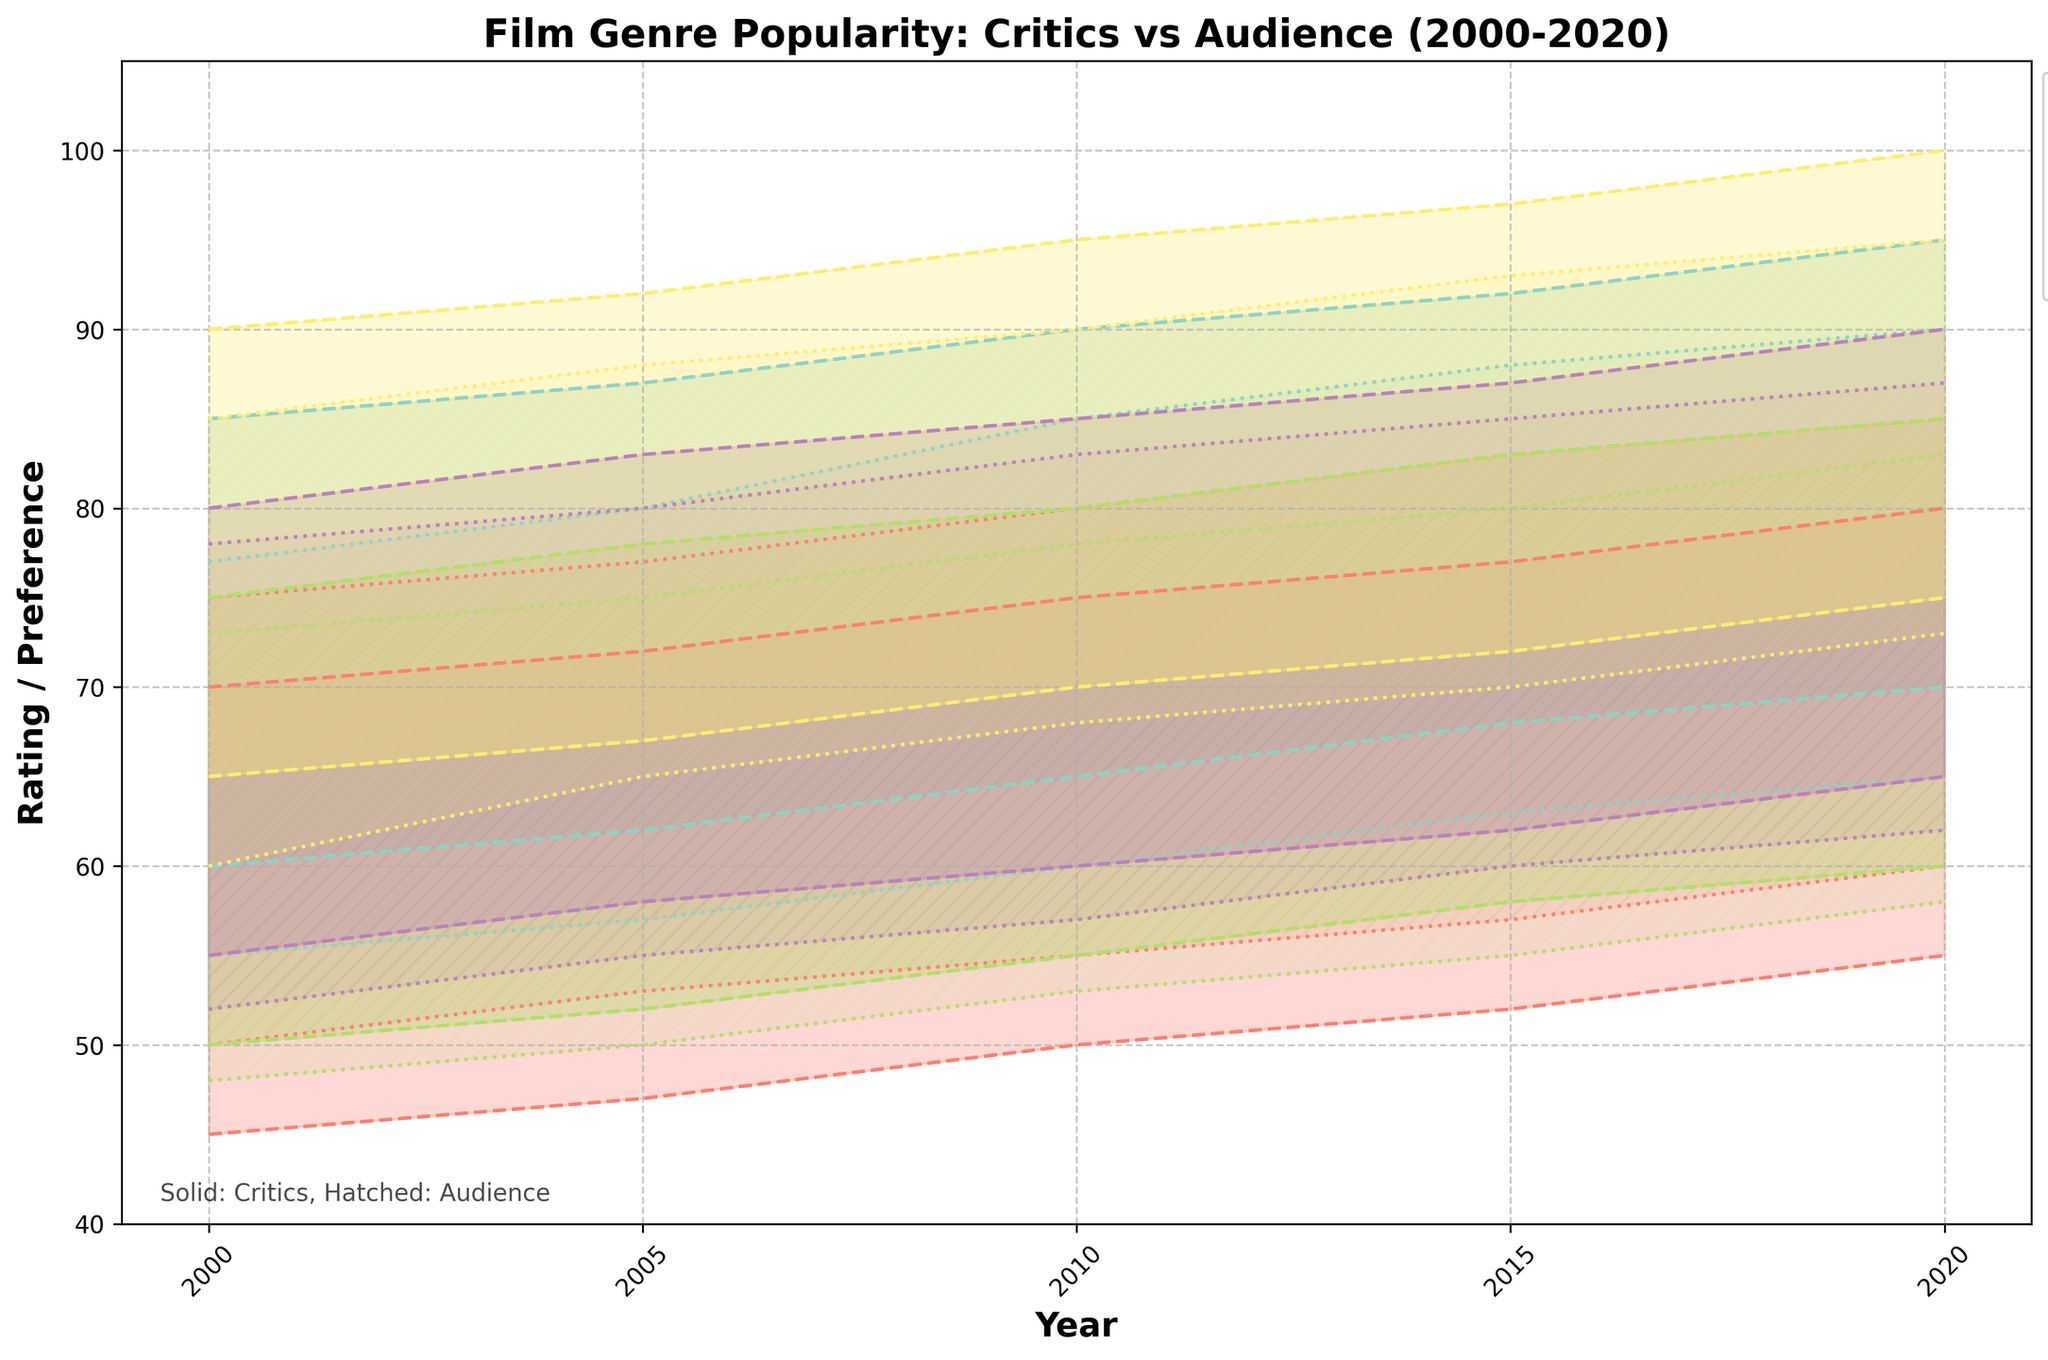What is the y-axis label in the plot? The y-axis label describes what is being measured on the y-axis. In the plot, it is indicated as 'Rating / Preference', which means both critic ratings and audience preferences are displayed on this axis.
Answer: Rating / Preference Which genre has the highest maximum critic rating in 2010? By looking at the maximum values on the top edge of each Genre's shaded area for the year 2010, Documentary reaches the highest value.
Answer: Documentary Between 2000 and 2020, which year saw the highest maximum audience preference for Romance films? By checking the top edge of the hatched areas for Romance from 2000 to 2020, 2020 shows the highest value.
Answer: 2020 For which genres did the minimum audience preference increase between 2000 and 2020? Comparing the bottom edge of the hatched areas from 2000 to 2020, the minimum audience preference increased for Drama, Comedy, Action, Romance, and Documentary.
Answer: Drama, Comedy, Action, Romance, Documentary Which genre had the smallest range between the minimum and maximum critic ratings in 2005? To determine the smallest range, calculate the difference between the minimum and maximum values for each genre in 2005; Comedy has the smallest difference of 25 (72-47).
Answer: Comedy What is the general trend for the maximum critic rating of Documentary films from 2000 to 2020? Observing the top edge of the shaded area for Documentary films, the maximum critic rating shows a steady increase from 90 in 2000 to 100 in 2020.
Answer: Increasing How do Drama and Documentary films compare in terms of maximum audience preference in 2020? Look at the top edge of the hatched area for Drama and Documentary in 2020. Documentary has a higher maximum audience preference (95) compared to Drama (90).
Answer: Documentary > Drama Which genre shows the widest range between the minimum and maximum audience preference in 2015? Calculating the difference between the minimum and maximum audience preferences for each genre in 2015, Documentary has the widest range with a difference of 23 (93-70).
Answer: Documentary How do the critic ratings for Comedy compare between 2000 and 2020 in terms of minimum and maximum values? Checking the range for Comedy in 2000 and 2020, the minimum critic rating increases from 45 to 55, and the maximum increases from 70 to 80.
Answer: Increase in both minimum and maximum What is the trend in audience preference for Action films from 2000 to 2020? Observing the hatched area for Action films, the minimum and maximum audience preferences show a gradual increase from 48-73 in 2000 to 58-83 in 2020.
Answer: Increasing 